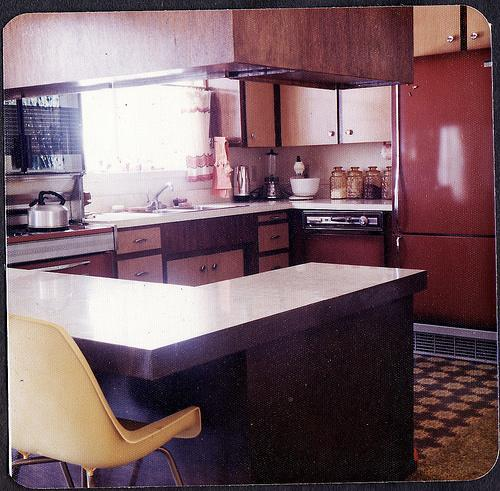What are the jars on the counter? Please explain your reasoning. canisters. This is the name applied to these types of storage containers in a kitchen. 